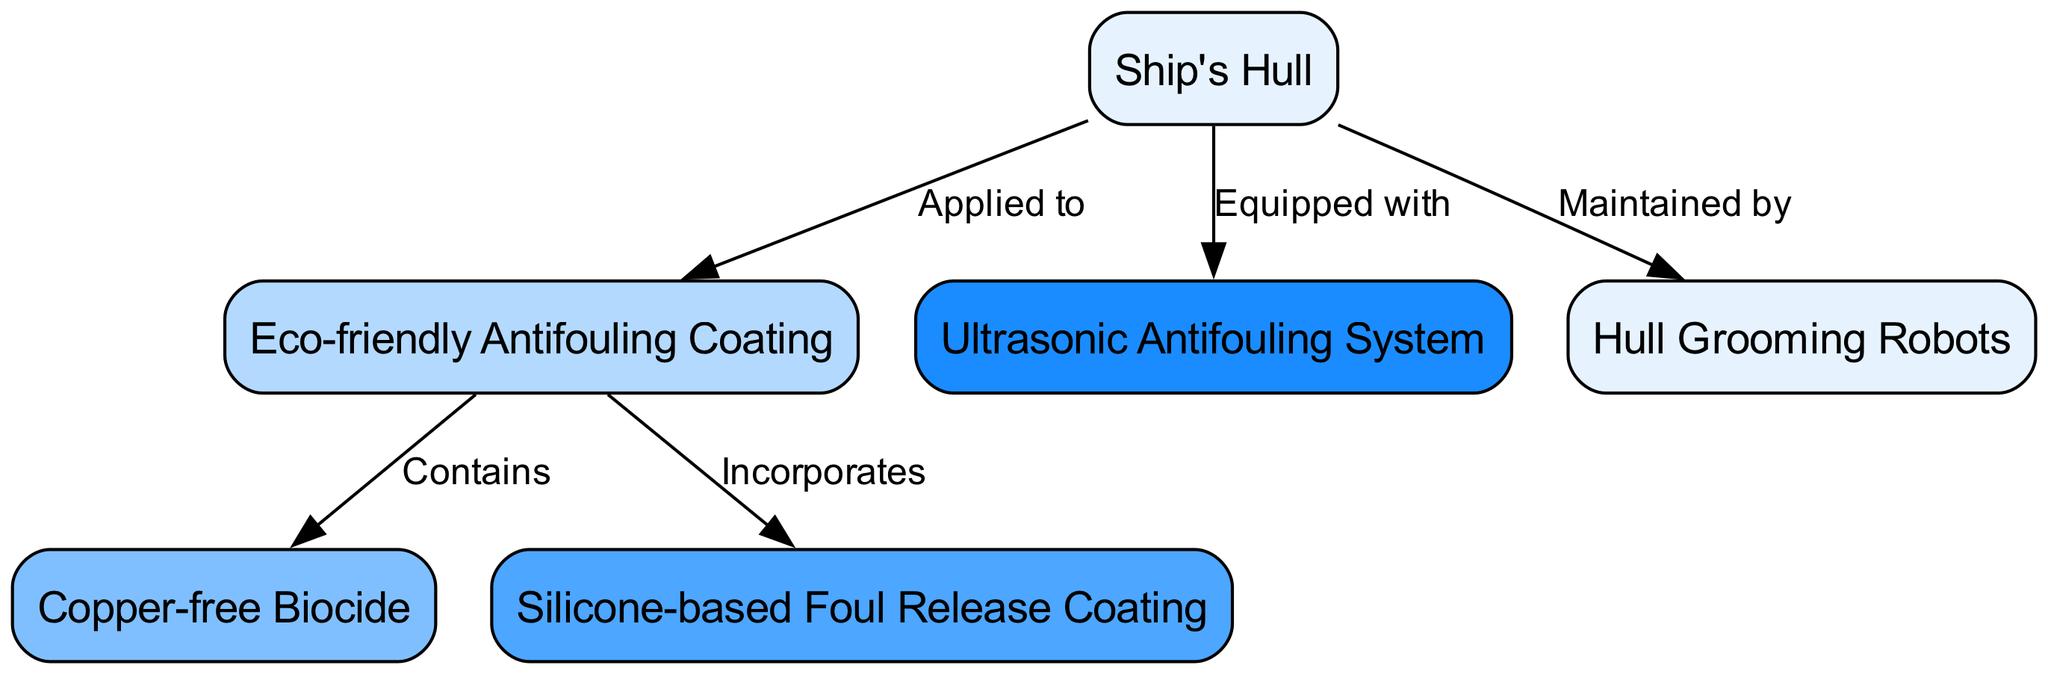What is the main component represented in the diagram? The primary node in the diagram is "Ship's Hull," which is the central focus of the eco-friendly measures depicted.
Answer: Ship's Hull How many nodes are present in the diagram? The diagram includes six distinct nodes: Ship's Hull, Eco-friendly Antifouling Coating, Copper-free Biocide, Silicone-based Foul Release Coating, Ultrasonic Antifouling System, and Hull Grooming Robots, totaling six.
Answer: 6 What does the "Eco-friendly Antifouling Coating" contain? The edges indicate that the "Eco-friendly Antifouling Coating" contains "Copper-free Biocide," which is directly connected to it.
Answer: Copper-free Biocide What technology is represented as being used for hull maintenance? The diagram shows "Hull Grooming Robots" as the technology dedicated to maintaining the ship's hull. This is indicated by the direct edge linking the hull to grooming robots.
Answer: Hull Grooming Robots How many ways are depicted for antifouling prevention measures? The diagram illustrates three antifouling prevention measures connected to the "Eco-friendly Antifouling Coating" node: Copper-free Biocide, Silicone-based Foul Release Coating, and Ultrasonic Antifouling System, totaling three.
Answer: 3 Which system is indicated as equipped to the ship's hull? The "Ultrasonic Antifouling System" is specifically shown as equipped to the ship's hull, highlighted by the edge depicting this relationship.
Answer: Ultrasonic Antifouling System What kind of coating is incorporated into the eco-friendly antifouling coating? The diagram shows that the "Eco-friendly Antifouling Coating" incorporates a "Silicone-based Foul Release Coating," indicating the dual nature of the coating's functionality.
Answer: Silicone-based Foul Release Coating Which component is applied directly to the ship's hull? The "Eco-friendly Antifouling Coating" is directly applied to the "Ship's Hull," as demonstrated by the connecting edge labeled "Applied to."
Answer: Eco-friendly Antifouling Coating What color scheme is generally used in the nodes of the diagram? The diagram employs a gradient color scheme, utilizing shades of blue (light blue to darker blue), which are distributed for visual differentiation among the nodes.
Answer: Shades of blue 